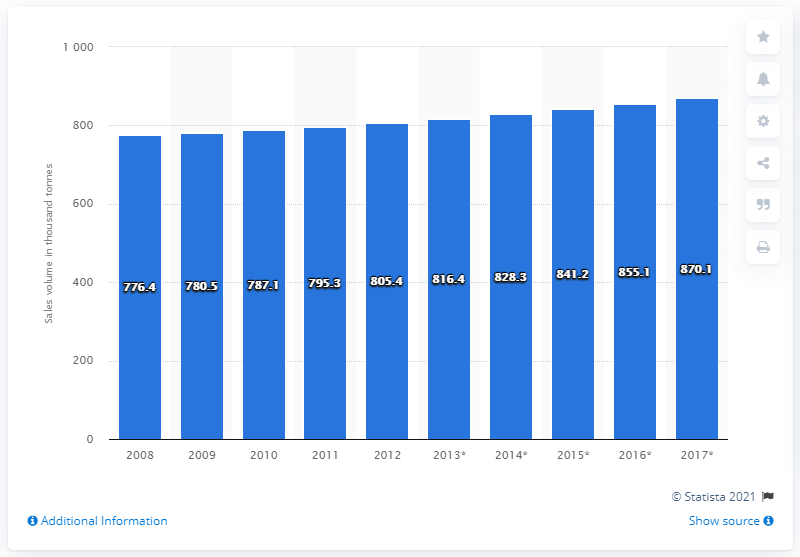Identify some key points in this picture. In 2008, the retail sales volume of fresh fish and seafood in the UK began to increase. 